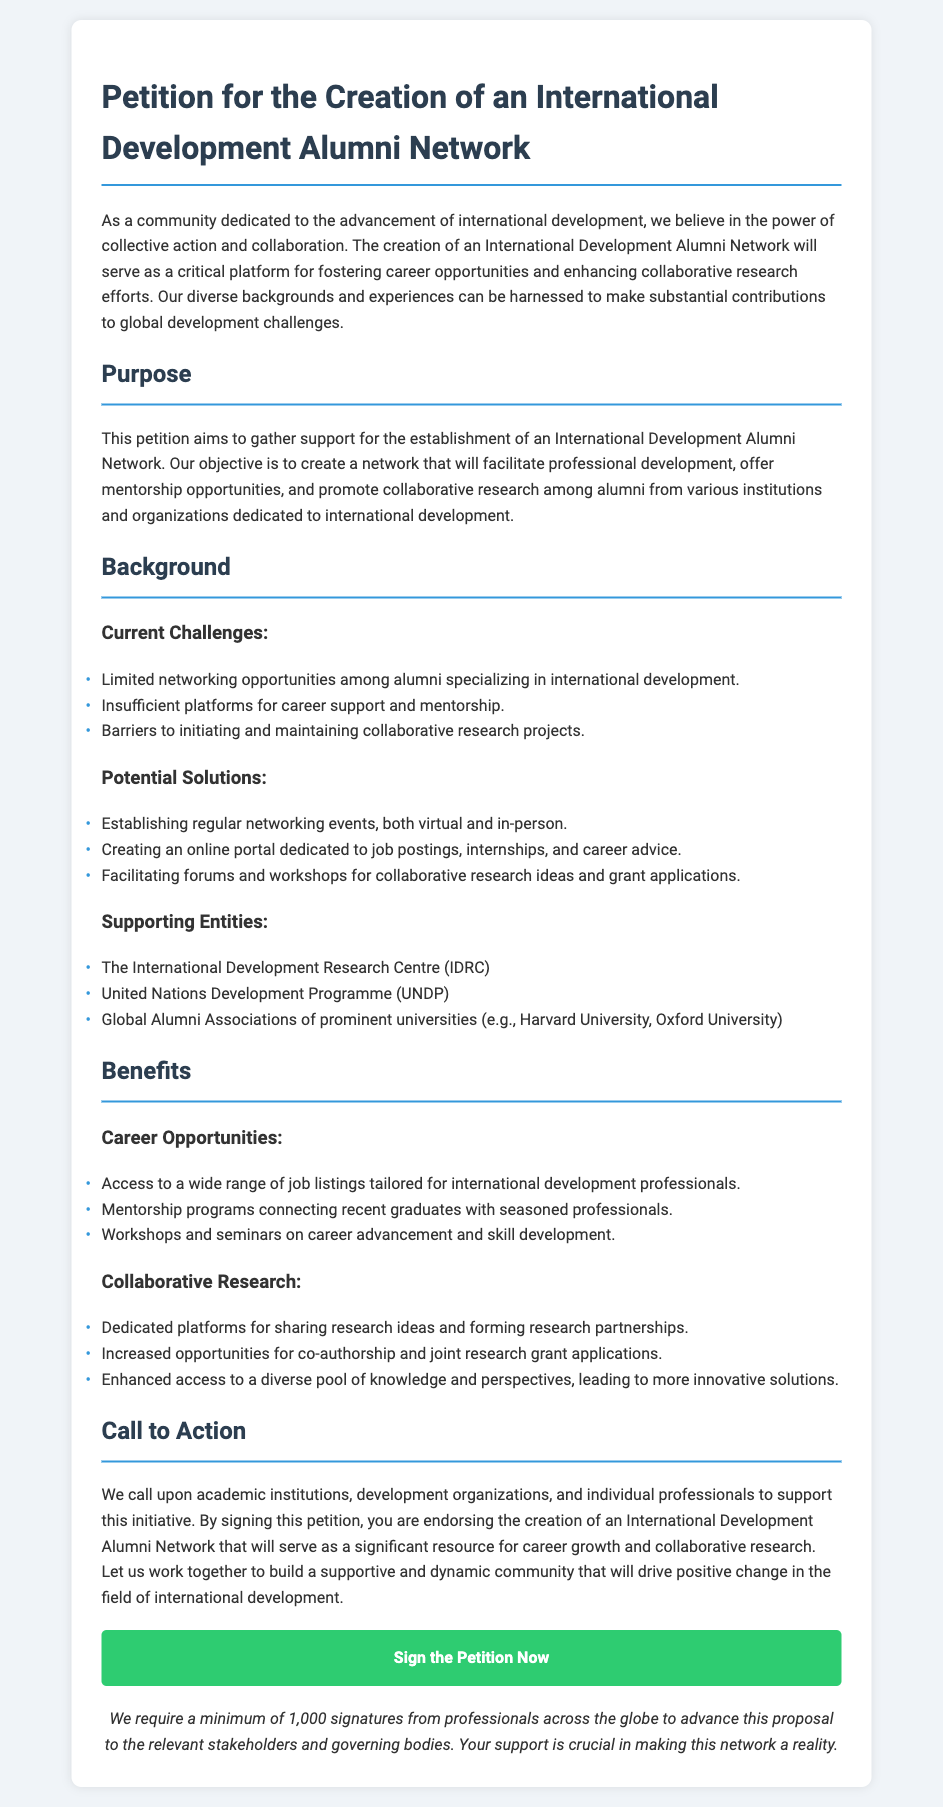What is the title of the petition? The title of the petition is stated clearly at the beginning of the document, which is "Petition for the Creation of an International Development Alumni Network."
Answer: Petition for the Creation of an International Development Alumni Network What entities are mentioned as supporting entities? The supporting entities listed in the document include organizations that would endorse the network, such as IDRC and UNDP.
Answer: The International Development Research Centre (IDRC), United Nations Development Programme (UNDP), Global Alumni Associations of prominent universities How many signatures are required to advance the proposal? The document specifies the minimum number of signatures necessary to proceed, which is mentioned in the call to action section.
Answer: 1,000 What is one of the current challenges listed in the Background section? The challenges are outlined in a bulleted list, and one of them explicitly mentions networking limitations.
Answer: Limited networking opportunities among alumni specializing in international development What is one proposed solution for enhancing collaborative research? The document lists potential solutions, including virtual and in-person events, indicating a strategy to build research collaboration.
Answer: Facilitating forums and workshops for collaborative research ideas and grant applications What is one benefit related to career opportunities mentioned in the document? The benefits section highlights multiple advantages, including access to job listings, which is tied to career support.
Answer: Access to a wide range of job listings tailored for international development professionals What is the main objective of the petition? The purpose of the petition is to outline the intent behind forming the alumni network, focusing on collaboration and career development.
Answer: To create a network that will facilitate professional development, offer mentorship opportunities, and promote collaborative research What type of action does the petition call for? The call to action invites a specific group of stakeholders to participate in a collaborative effort, emphasizing the need for support and involvement.
Answer: Support this initiative 